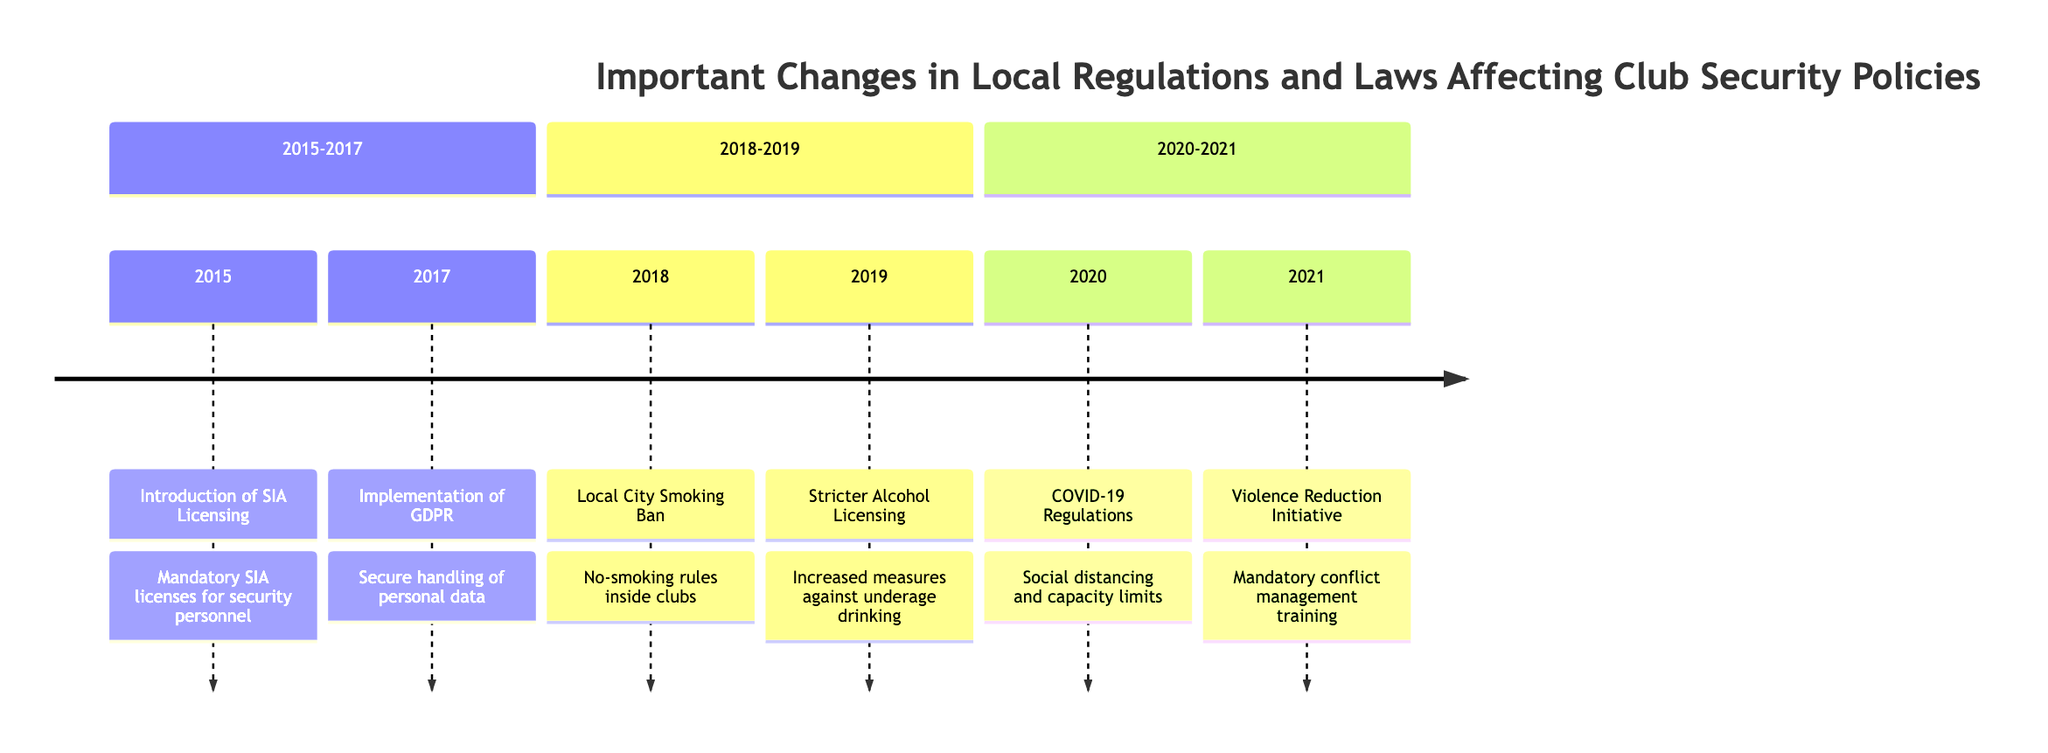What year was the introduction of the SIA Licensing? The diagram states that the introduction of the SIA Licensing occurred in 2015, as indicated in the first entry of the timeline.
Answer: 2015 What event took place in 2020? According to the timeline, the event listed for 2020 is the implementation of COVID-19 Health and Safety Regulations, found in the appropriate section of that year.
Answer: Implementation of COVID-19 Health and Safety Regulations How many events are listed in the timeline from 2018 to 2019? Counting the listed events in the section for 2018 to 2019, there are two events: the Local City Smoking Ban in 2018 and the Stricter Alcohol Licensing Policies in 2019.
Answer: 2 Which regulation requires security personnel to manage entry control and compliance checks? The event labeled "Implementation of COVID-19 Health and Safety Regulations" is the one requiring security personnel to manage increased entry control and compliance checks, as noted in the description.
Answer: COVID-19 Health and Safety Regulations What was mandated for all security staff in 2021? The timeline describes the Violence Reduction Initiative implemented in 2021, which mandated conflict management training for all security staff.
Answer: Mandatory conflict management training In which year did the Local City Smoking Ban come into effect? The diagram indicates that the Local City Smoking Ban came into effect in 2018, as shown in the corresponding entry for that year.
Answer: 2018 What relationship exists between GDPR implementation and data handling? The implementation of GDPR in 2017 necessitates that clubs ensure the secure handling of personal data, highlighting a direct connection between the regulation and data handling practices.
Answer: Secure handling of personal data Which two years feature increased security measures due to regulatory changes? The years 2019 (Stricter Alcohol Licensing Policies) and 2021 (Violence Reduction Initiative) encompass changes necessitating increased security measures.
Answer: 2019 and 2021 What was the focus shift for security personnel with the smoking ban? With the Local City Smoking Ban enacted in 2018, the focus shifted for security personnel towards managing designated smoking areas instead of monitoring indoor smoking.
Answer: Designated smoking areas 